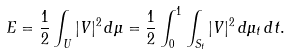Convert formula to latex. <formula><loc_0><loc_0><loc_500><loc_500>E = \frac { 1 } { 2 } \int _ { U } | V | ^ { 2 } \, d \mu = \frac { 1 } { 2 } \int _ { 0 } ^ { 1 } \int _ { S _ { t } } | V | ^ { 2 } \, d \mu _ { t } \, d t .</formula> 